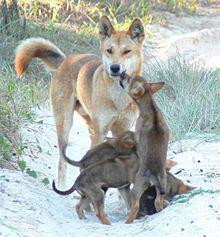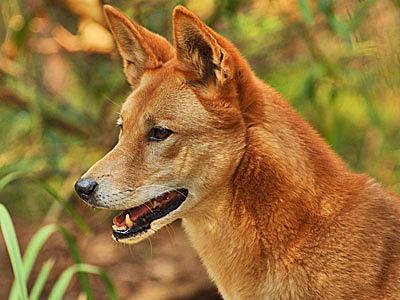The first image is the image on the left, the second image is the image on the right. Analyze the images presented: Is the assertion "One of the images contains at least two dogs." valid? Answer yes or no. Yes. 